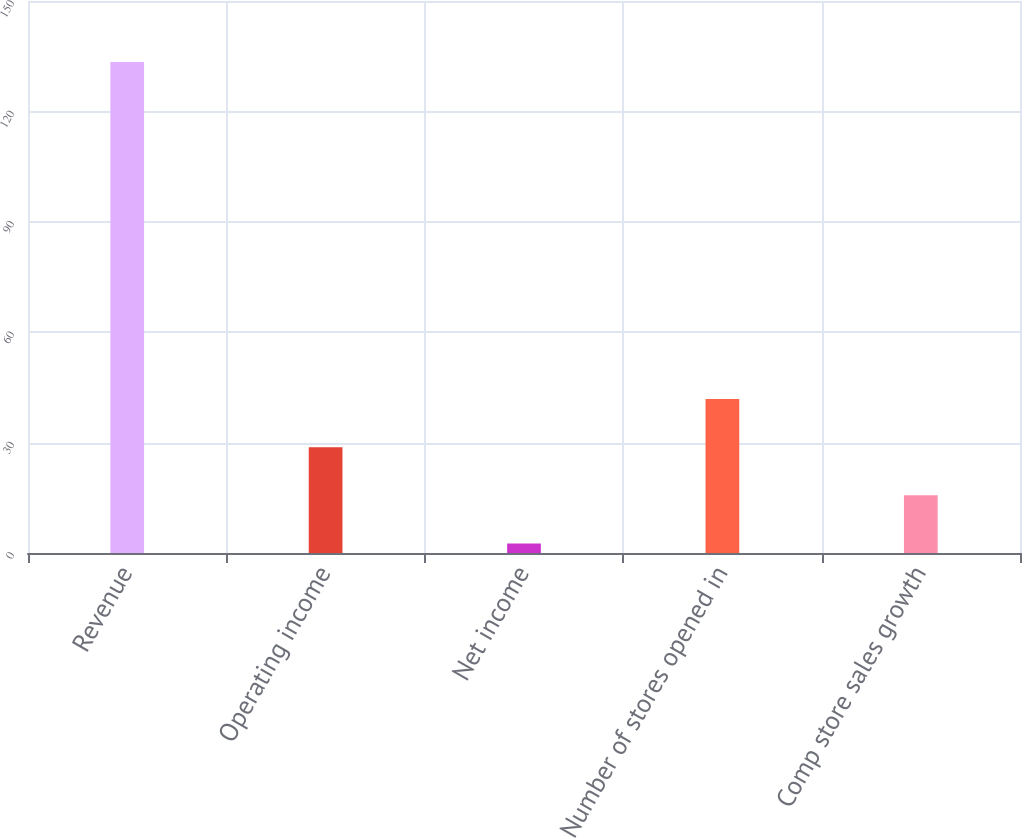Convert chart. <chart><loc_0><loc_0><loc_500><loc_500><bar_chart><fcel>Revenue<fcel>Operating income<fcel>Net income<fcel>Number of stores opened in<fcel>Comp store sales growth<nl><fcel>133.4<fcel>28.76<fcel>2.6<fcel>41.84<fcel>15.68<nl></chart> 